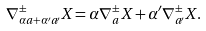Convert formula to latex. <formula><loc_0><loc_0><loc_500><loc_500>\nabla _ { \alpha a + \alpha ^ { \prime } a ^ { \prime } } ^ { \pm } X = \alpha \nabla _ { a } ^ { \pm } X + \alpha ^ { \prime } \nabla _ { a ^ { \prime } } ^ { \pm } X .</formula> 